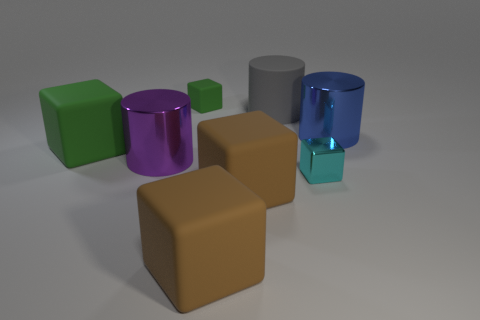What is the color of the cylinder that is in front of the rubber cylinder and right of the tiny green object?
Your answer should be very brief. Blue. There is a shiny object right of the small cyan metallic block; what is its shape?
Make the answer very short. Cylinder. What is the size of the green matte block that is right of the green block in front of the large thing that is on the right side of the cyan cube?
Your answer should be compact. Small. There is a green block behind the blue thing; what number of small green matte things are behind it?
Keep it short and to the point. 0. What size is the object that is in front of the big green thing and on the left side of the small green matte cube?
Your answer should be very brief. Large. How many matte objects are either small yellow balls or purple cylinders?
Your response must be concise. 0. What is the material of the cyan object?
Provide a succinct answer. Metal. The green cube left of the tiny block that is behind the large purple metallic cylinder left of the gray rubber thing is made of what material?
Offer a very short reply. Rubber. What shape is the blue metallic thing that is the same size as the gray rubber cylinder?
Provide a succinct answer. Cylinder. What number of things are either cyan rubber blocks or big green blocks that are in front of the big gray cylinder?
Give a very brief answer. 1. 